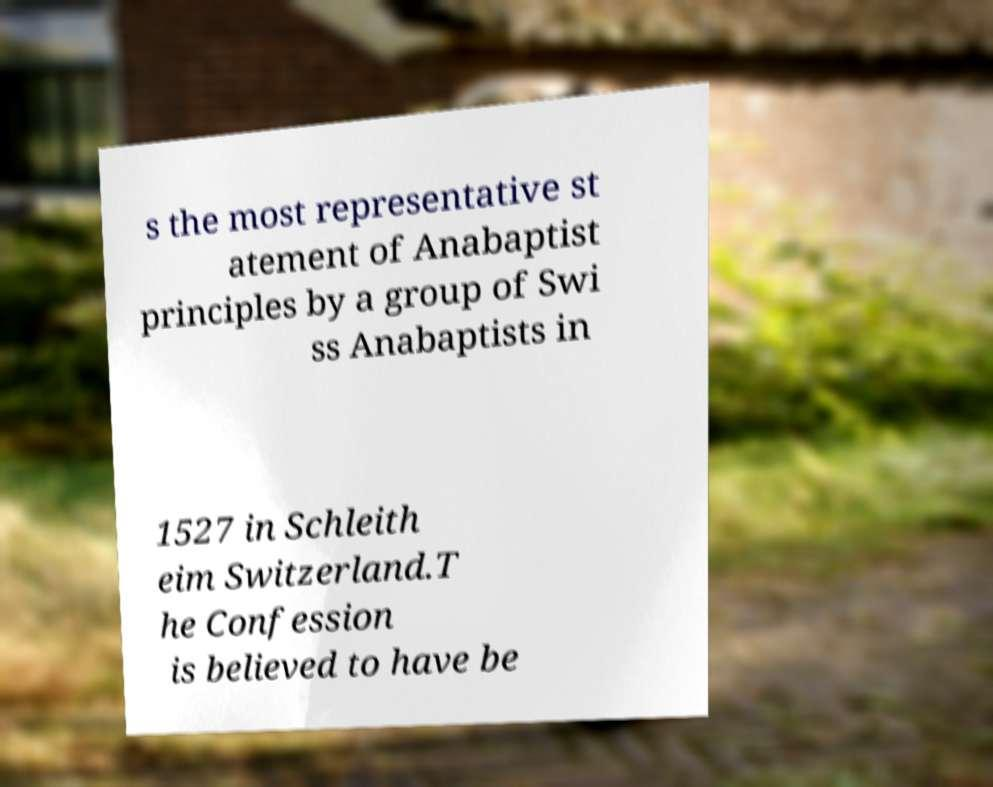What messages or text are displayed in this image? I need them in a readable, typed format. s the most representative st atement of Anabaptist principles by a group of Swi ss Anabaptists in 1527 in Schleith eim Switzerland.T he Confession is believed to have be 